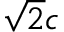<formula> <loc_0><loc_0><loc_500><loc_500>\sqrt { 2 } c</formula> 